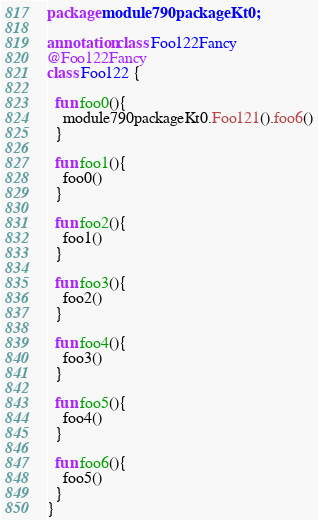Convert code to text. <code><loc_0><loc_0><loc_500><loc_500><_Kotlin_>package module790packageKt0;

annotation class Foo122Fancy
@Foo122Fancy
class Foo122 {

  fun foo0(){
    module790packageKt0.Foo121().foo6()
  }

  fun foo1(){
    foo0()
  }

  fun foo2(){
    foo1()
  }

  fun foo3(){
    foo2()
  }

  fun foo4(){
    foo3()
  }

  fun foo5(){
    foo4()
  }

  fun foo6(){
    foo5()
  }
}</code> 